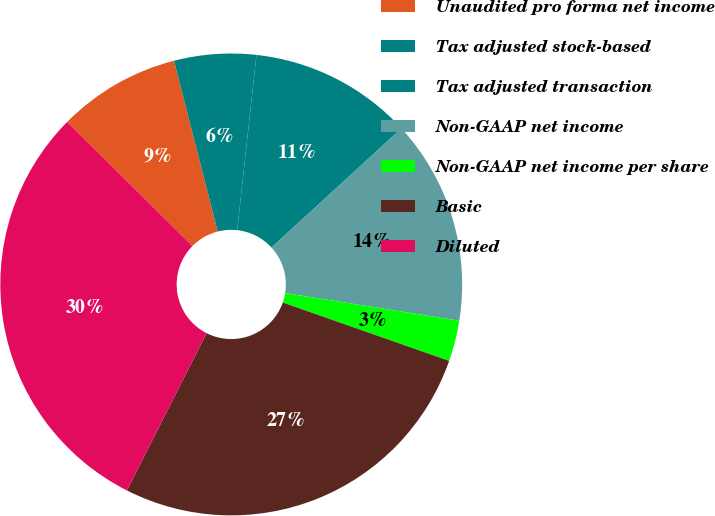<chart> <loc_0><loc_0><loc_500><loc_500><pie_chart><fcel>Unaudited pro forma net income<fcel>Tax adjusted stock-based<fcel>Tax adjusted transaction<fcel>Non-GAAP net income<fcel>Non-GAAP net income per share<fcel>Basic<fcel>Diluted<nl><fcel>8.59%<fcel>5.73%<fcel>11.45%<fcel>14.32%<fcel>2.86%<fcel>27.09%<fcel>29.96%<nl></chart> 